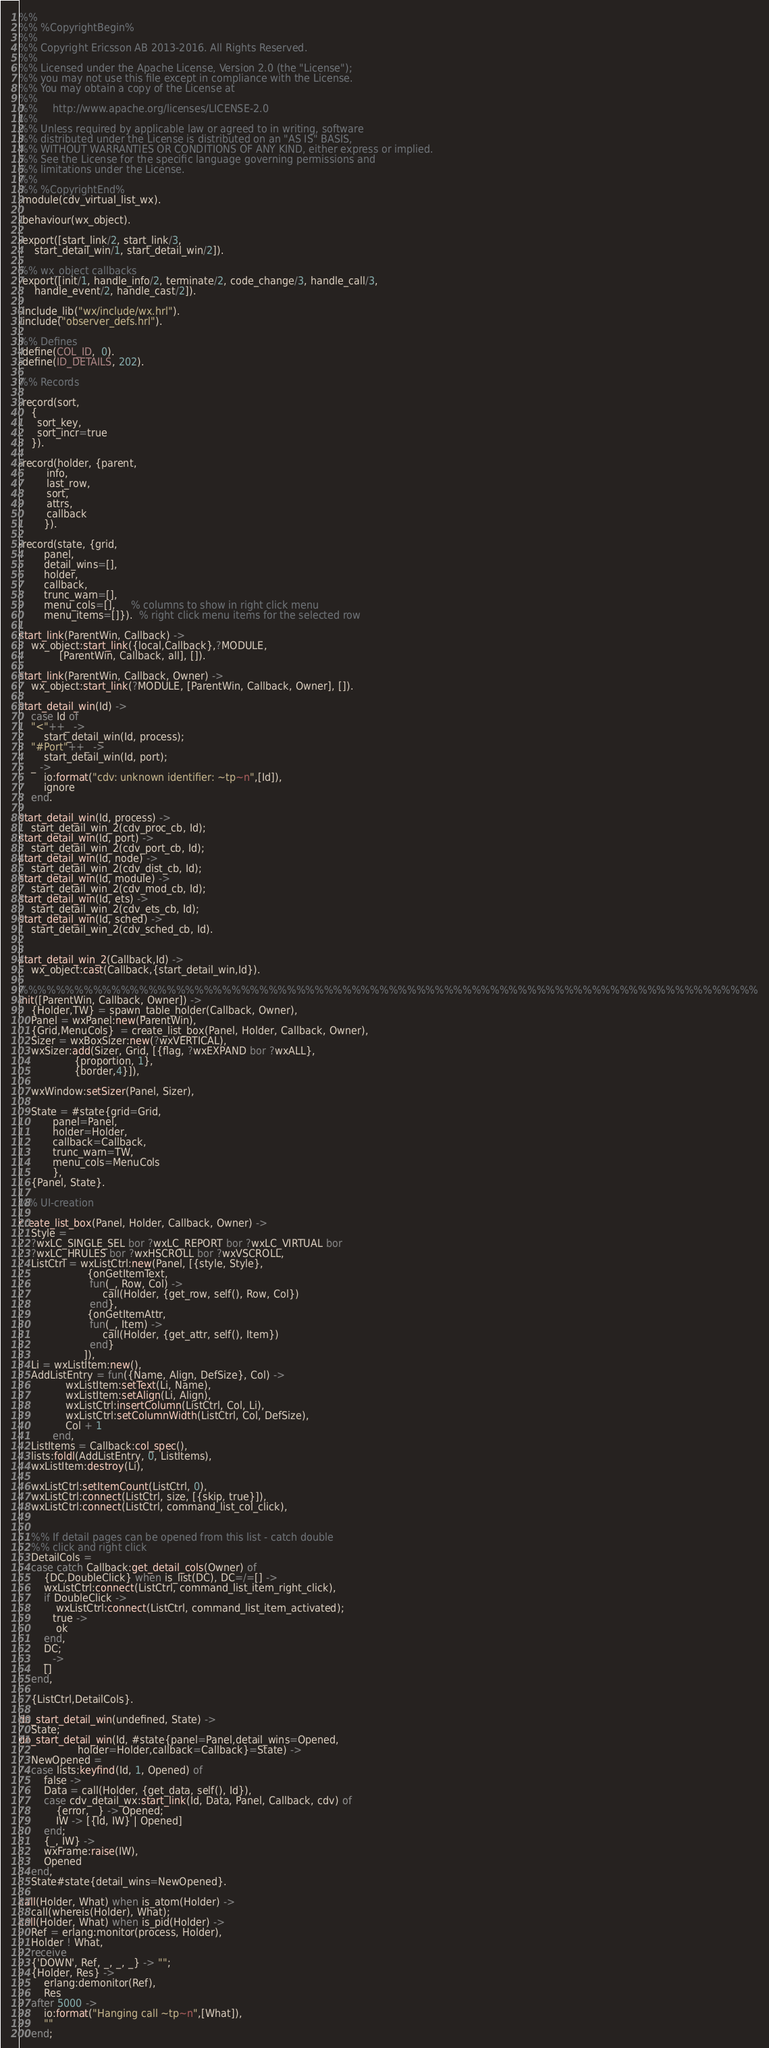<code> <loc_0><loc_0><loc_500><loc_500><_Erlang_>%%
%% %CopyrightBegin%
%%
%% Copyright Ericsson AB 2013-2016. All Rights Reserved.
%%
%% Licensed under the Apache License, Version 2.0 (the "License");
%% you may not use this file except in compliance with the License.
%% You may obtain a copy of the License at
%%
%%     http://www.apache.org/licenses/LICENSE-2.0
%%
%% Unless required by applicable law or agreed to in writing, software
%% distributed under the License is distributed on an "AS IS" BASIS,
%% WITHOUT WARRANTIES OR CONDITIONS OF ANY KIND, either express or implied.
%% See the License for the specific language governing permissions and
%% limitations under the License.
%%
%% %CopyrightEnd%
-module(cdv_virtual_list_wx).

-behaviour(wx_object).

-export([start_link/2, start_link/3,
	 start_detail_win/1, start_detail_win/2]).

%% wx_object callbacks
-export([init/1, handle_info/2, terminate/2, code_change/3, handle_call/3,
	 handle_event/2, handle_cast/2]).

-include_lib("wx/include/wx.hrl").
-include("observer_defs.hrl").

%% Defines
-define(COL_ID,  0).
-define(ID_DETAILS, 202).

%% Records

-record(sort,
	{
	  sort_key,
	  sort_incr=true
	}).

-record(holder, {parent,
		 info,
		 last_row,
		 sort,
		 attrs,
		 callback
		}).

-record(state, {grid,
		panel,
		detail_wins=[],
		holder,
		callback,
		trunc_warn=[],
		menu_cols=[],     % columns to show in right click menu
		menu_items=[]}).  % right click menu items for the selected row

start_link(ParentWin, Callback) ->
    wx_object:start_link({local,Callback},?MODULE,
			 [ParentWin, Callback, all], []).

start_link(ParentWin, Callback, Owner) ->
    wx_object:start_link(?MODULE, [ParentWin, Callback, Owner], []).

start_detail_win(Id) ->
    case Id of
	"<"++_ ->
	    start_detail_win(Id, process);
	"#Port"++_ ->
	    start_detail_win(Id, port);
	_ ->
	    io:format("cdv: unknown identifier: ~tp~n",[Id]),
	    ignore
    end.

start_detail_win(Id, process) ->
    start_detail_win_2(cdv_proc_cb, Id);
start_detail_win(Id, port) ->
    start_detail_win_2(cdv_port_cb, Id);
start_detail_win(Id, node) ->
    start_detail_win_2(cdv_dist_cb, Id);
start_detail_win(Id, module) ->
    start_detail_win_2(cdv_mod_cb, Id);
start_detail_win(Id, ets) ->
    start_detail_win_2(cdv_ets_cb, Id);
start_detail_win(Id, sched) ->
    start_detail_win_2(cdv_sched_cb, Id).


start_detail_win_2(Callback,Id) ->
    wx_object:cast(Callback,{start_detail_win,Id}).

%%%%%%%%%%%%%%%%%%%%%%%%%%%%%%%%%%%%%%%%%%%%%%%%%%%%%%%%%%%%%%%%%%%%%%%%%%%%%%%%
init([ParentWin, Callback, Owner]) ->
    {Holder,TW} = spawn_table_holder(Callback, Owner),
    Panel = wxPanel:new(ParentWin),
    {Grid,MenuCols}  = create_list_box(Panel, Holder, Callback, Owner),
    Sizer = wxBoxSizer:new(?wxVERTICAL),
    wxSizer:add(Sizer, Grid, [{flag, ?wxEXPAND bor ?wxALL},
			      {proportion, 1},
			      {border,4}]),

    wxWindow:setSizer(Panel, Sizer),

    State = #state{grid=Grid,
		   panel=Panel,
		   holder=Holder,
		   callback=Callback,
		   trunc_warn=TW,
		   menu_cols=MenuCols
		   },
    {Panel, State}.

%% UI-creation

create_list_box(Panel, Holder, Callback, Owner) ->
    Style =
	?wxLC_SINGLE_SEL bor ?wxLC_REPORT bor ?wxLC_VIRTUAL bor
	?wxLC_HRULES bor ?wxHSCROLL bor ?wxVSCROLL,
    ListCtrl = wxListCtrl:new(Panel, [{style, Style},
				      {onGetItemText,
				       fun(_, Row, Col) ->
					       call(Holder, {get_row, self(), Row, Col})
				       end},
				      {onGetItemAttr,
				       fun(_, Item) ->
					       call(Holder, {get_attr, self(), Item})
				       end}
				     ]),
    Li = wxListItem:new(),
    AddListEntry = fun({Name, Align, DefSize}, Col) ->
			   wxListItem:setText(Li, Name),
			   wxListItem:setAlign(Li, Align),
			   wxListCtrl:insertColumn(ListCtrl, Col, Li),
			   wxListCtrl:setColumnWidth(ListCtrl, Col, DefSize),
			   Col + 1
		   end,
    ListItems = Callback:col_spec(),
    lists:foldl(AddListEntry, 0, ListItems),
    wxListItem:destroy(Li),

    wxListCtrl:setItemCount(ListCtrl, 0),
    wxListCtrl:connect(ListCtrl, size, [{skip, true}]),
    wxListCtrl:connect(ListCtrl, command_list_col_click),


    %% If detail pages can be opened from this list - catch double
    %% click and right click
    DetailCols =
	case catch Callback:get_detail_cols(Owner) of
	    {DC,DoubleClick} when is_list(DC), DC=/=[] ->
		wxListCtrl:connect(ListCtrl, command_list_item_right_click),
		if DoubleClick ->
			wxListCtrl:connect(ListCtrl, command_list_item_activated);
		   true ->
			ok
		end,
		DC;
	    _ ->
		[]
	end,

    {ListCtrl,DetailCols}.

do_start_detail_win(undefined, State) ->
    State;
do_start_detail_win(Id, #state{panel=Panel,detail_wins=Opened,
			       holder=Holder,callback=Callback}=State) ->
    NewOpened =
	case lists:keyfind(Id, 1, Opened) of
	    false ->
		Data = call(Holder, {get_data, self(), Id}),
		case cdv_detail_wx:start_link(Id, Data, Panel, Callback, cdv) of
		    {error, _} -> Opened;
		    IW -> [{Id, IW} | Opened]
		end;
	    {_, IW} ->
		wxFrame:raise(IW),
		Opened
	end,
    State#state{detail_wins=NewOpened}.

call(Holder, What) when is_atom(Holder) ->
    call(whereis(Holder), What);
call(Holder, What) when is_pid(Holder) ->
    Ref = erlang:monitor(process, Holder),
    Holder ! What,
    receive
	{'DOWN', Ref, _, _, _} -> "";
	{Holder, Res} ->
	    erlang:demonitor(Ref),
	    Res
    after 5000 ->
	    io:format("Hanging call ~tp~n",[What]),
	    ""
    end;</code> 